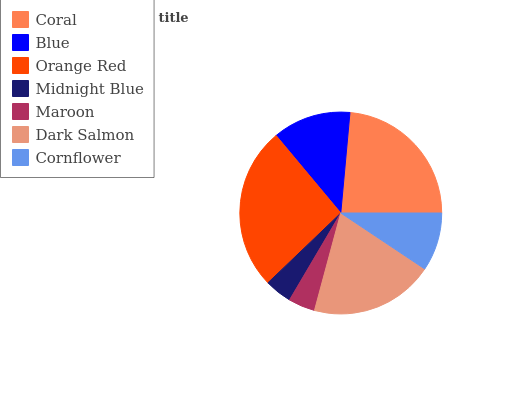Is Maroon the minimum?
Answer yes or no. Yes. Is Orange Red the maximum?
Answer yes or no. Yes. Is Blue the minimum?
Answer yes or no. No. Is Blue the maximum?
Answer yes or no. No. Is Coral greater than Blue?
Answer yes or no. Yes. Is Blue less than Coral?
Answer yes or no. Yes. Is Blue greater than Coral?
Answer yes or no. No. Is Coral less than Blue?
Answer yes or no. No. Is Blue the high median?
Answer yes or no. Yes. Is Blue the low median?
Answer yes or no. Yes. Is Dark Salmon the high median?
Answer yes or no. No. Is Maroon the low median?
Answer yes or no. No. 